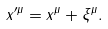Convert formula to latex. <formula><loc_0><loc_0><loc_500><loc_500>x ^ { \prime \mu } = x ^ { \mu } + \xi ^ { \mu } .</formula> 